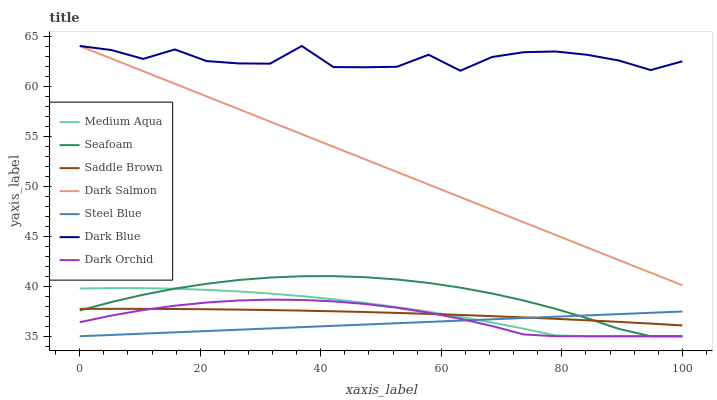Does Steel Blue have the minimum area under the curve?
Answer yes or no. Yes. Does Dark Blue have the maximum area under the curve?
Answer yes or no. Yes. Does Dark Salmon have the minimum area under the curve?
Answer yes or no. No. Does Dark Salmon have the maximum area under the curve?
Answer yes or no. No. Is Steel Blue the smoothest?
Answer yes or no. Yes. Is Dark Blue the roughest?
Answer yes or no. Yes. Is Dark Salmon the smoothest?
Answer yes or no. No. Is Dark Salmon the roughest?
Answer yes or no. No. Does Seafoam have the lowest value?
Answer yes or no. Yes. Does Dark Salmon have the lowest value?
Answer yes or no. No. Does Dark Blue have the highest value?
Answer yes or no. Yes. Does Dark Orchid have the highest value?
Answer yes or no. No. Is Dark Orchid less than Dark Blue?
Answer yes or no. Yes. Is Dark Salmon greater than Seafoam?
Answer yes or no. Yes. Does Steel Blue intersect Medium Aqua?
Answer yes or no. Yes. Is Steel Blue less than Medium Aqua?
Answer yes or no. No. Is Steel Blue greater than Medium Aqua?
Answer yes or no. No. Does Dark Orchid intersect Dark Blue?
Answer yes or no. No. 